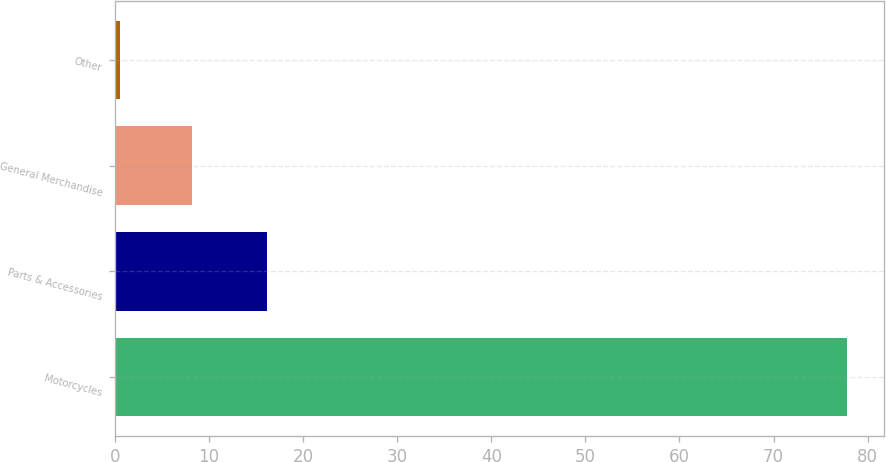Convert chart. <chart><loc_0><loc_0><loc_500><loc_500><bar_chart><fcel>Motorcycles<fcel>Parts & Accessories<fcel>General Merchandise<fcel>Other<nl><fcel>77.8<fcel>16.2<fcel>8.23<fcel>0.5<nl></chart> 